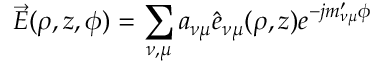Convert formula to latex. <formula><loc_0><loc_0><loc_500><loc_500>\vec { E } ( \rho , z , \phi ) = \sum _ { \nu , \mu } a _ { \nu \mu } { \hat { e } } _ { \nu \mu } ( \rho , z ) e ^ { - j m _ { \nu \mu } ^ { \prime } \phi }</formula> 